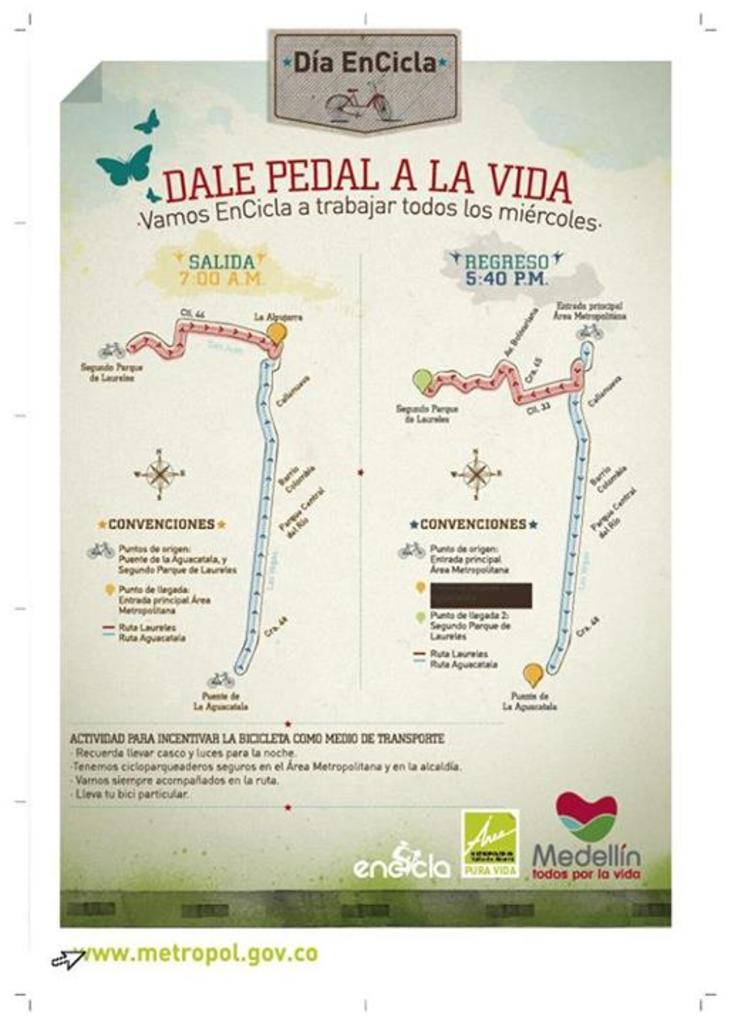<image>
Relay a brief, clear account of the picture shown. A map in color titled "Dia EnCrcla" with a bicycle under the title. 